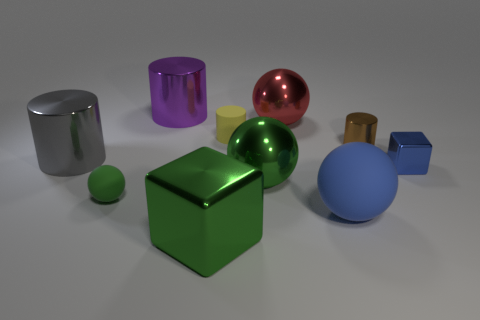Can you describe the colors and shapes present in the image? Certainly! In the image, you can observe a variety of colors and shapes. There's a large green sphere with a glossy finish at the forefront, alongside a metallic cube to its right. You'll also notice a red shiny sphere, a blue matte sphere, and several cylinders and cubes in colors such as purple, yellow, gold, and blue. All objects are resting on a flat surface under bright, soft lighting, which adds to the overall aesthetics by creating subtle reflections and shadows. 